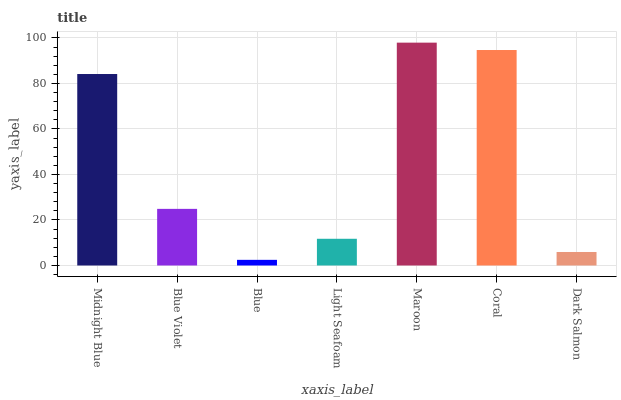Is Blue Violet the minimum?
Answer yes or no. No. Is Blue Violet the maximum?
Answer yes or no. No. Is Midnight Blue greater than Blue Violet?
Answer yes or no. Yes. Is Blue Violet less than Midnight Blue?
Answer yes or no. Yes. Is Blue Violet greater than Midnight Blue?
Answer yes or no. No. Is Midnight Blue less than Blue Violet?
Answer yes or no. No. Is Blue Violet the high median?
Answer yes or no. Yes. Is Blue Violet the low median?
Answer yes or no. Yes. Is Maroon the high median?
Answer yes or no. No. Is Dark Salmon the low median?
Answer yes or no. No. 